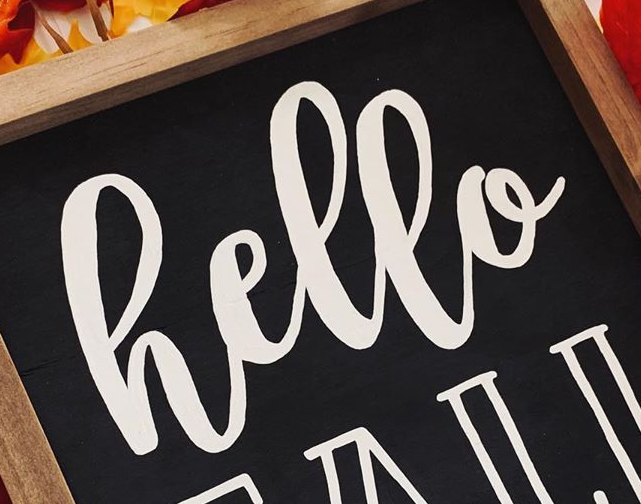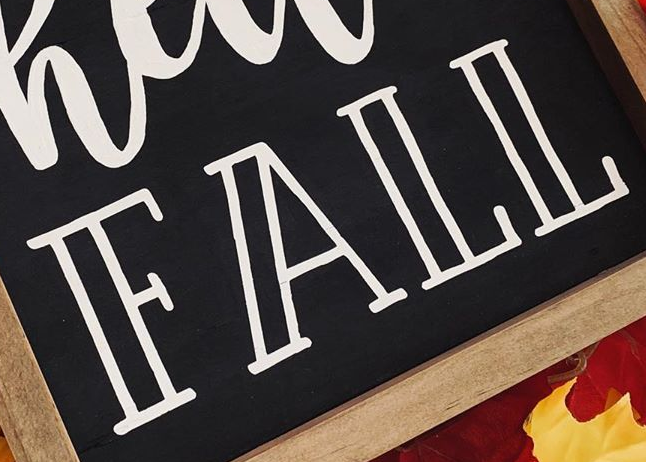What words can you see in these images in sequence, separated by a semicolon? hello; FALL 